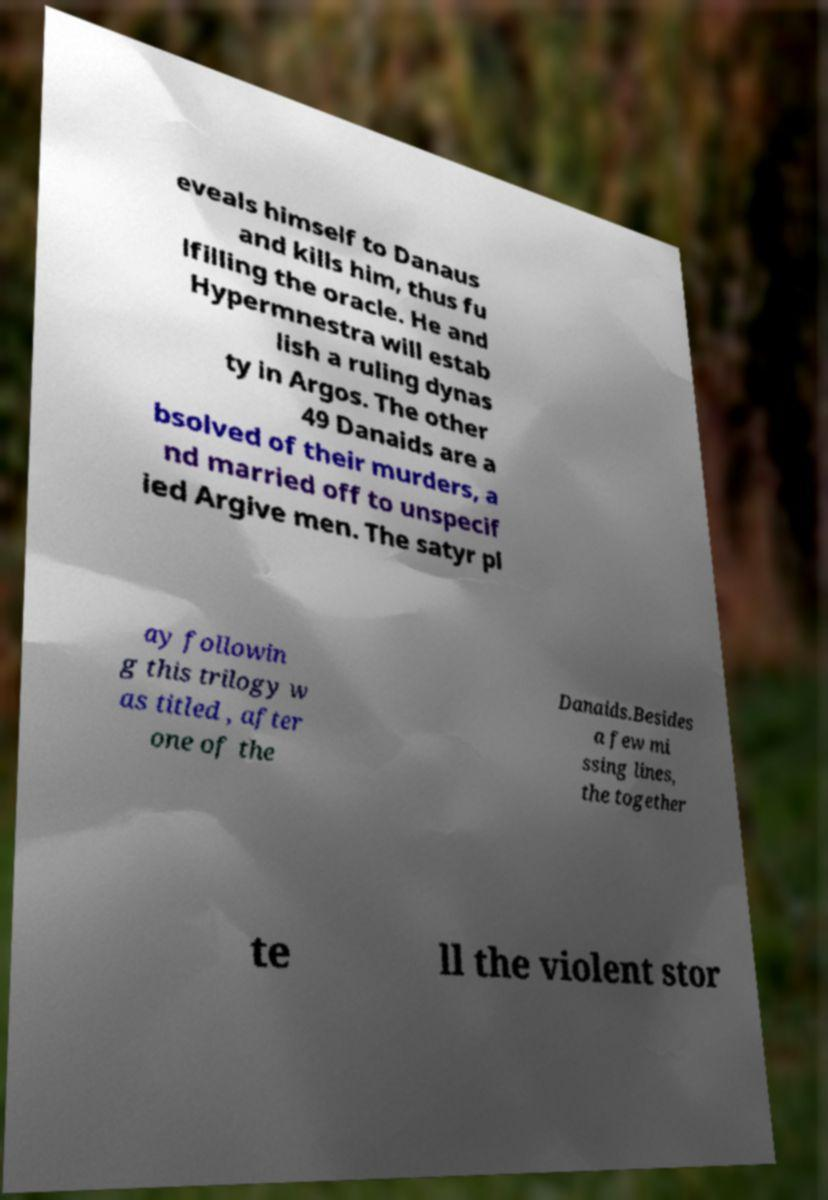Could you assist in decoding the text presented in this image and type it out clearly? eveals himself to Danaus and kills him, thus fu lfilling the oracle. He and Hypermnestra will estab lish a ruling dynas ty in Argos. The other 49 Danaids are a bsolved of their murders, a nd married off to unspecif ied Argive men. The satyr pl ay followin g this trilogy w as titled , after one of the Danaids.Besides a few mi ssing lines, the together te ll the violent stor 